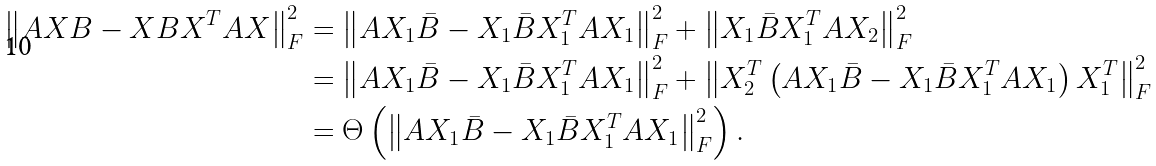<formula> <loc_0><loc_0><loc_500><loc_500>\left \| A X B - X B X ^ { T } A X \right \| _ { F } ^ { 2 } & = \left \| A X _ { 1 } \bar { B } - X _ { 1 } \bar { B } X _ { 1 } ^ { T } A X _ { 1 } \right \| _ { F } ^ { 2 } + \left \| X _ { 1 } \bar { B } X _ { 1 } ^ { T } A X _ { 2 } \right \| _ { F } ^ { 2 } \\ & = \left \| A X _ { 1 } \bar { B } - X _ { 1 } \bar { B } X _ { 1 } ^ { T } A X _ { 1 } \right \| _ { F } ^ { 2 } + \left \| X _ { 2 } ^ { T } \left ( A X _ { 1 } \bar { B } - X _ { 1 } \bar { B } X _ { 1 } ^ { T } A X _ { 1 } \right ) X _ { 1 } ^ { T } \right \| _ { F } ^ { 2 } \\ & = \Theta \left ( \left \| A X _ { 1 } \bar { B } - X _ { 1 } \bar { B } X _ { 1 } ^ { T } A X _ { 1 } \right \| _ { F } ^ { 2 } \right ) .</formula> 